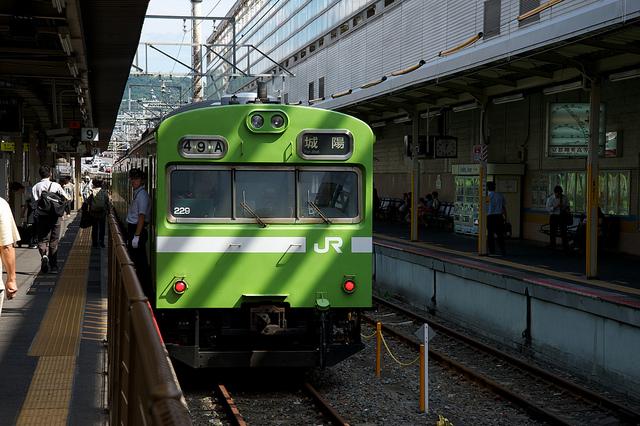What number is the train?
Keep it brief. 49. What color is the train?
Keep it brief. Green. What color the right headlight on this train?
Short answer required. Red. What color is train?
Short answer required. Green. 